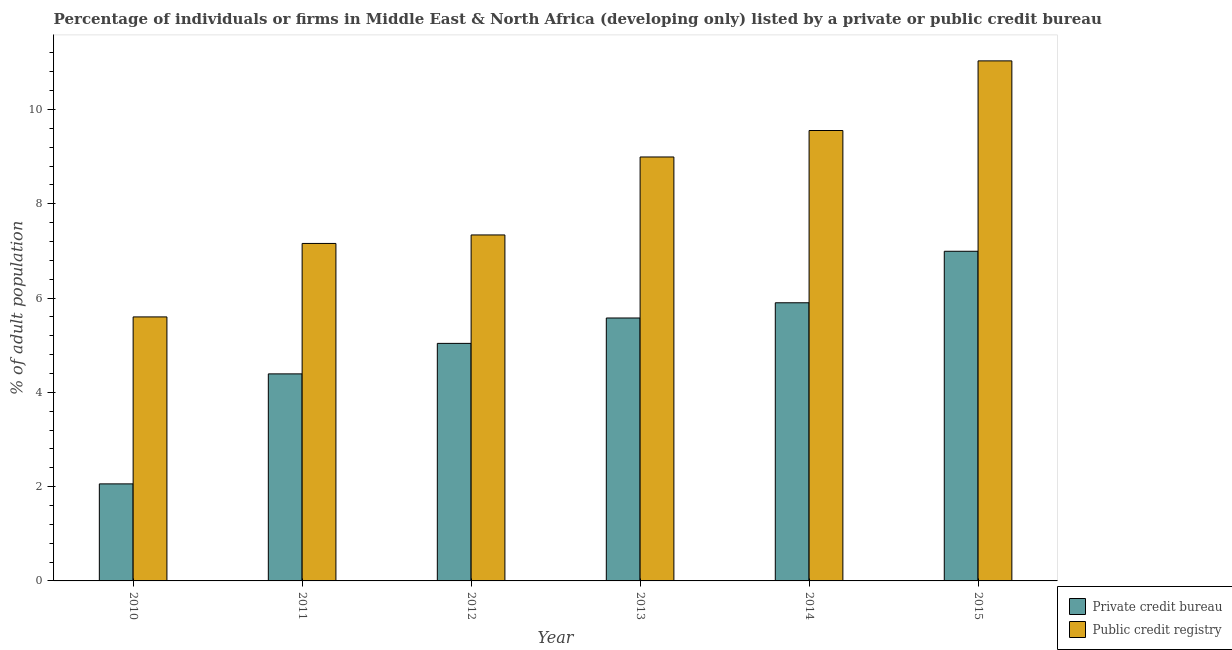How many groups of bars are there?
Ensure brevity in your answer.  6. Are the number of bars on each tick of the X-axis equal?
Your answer should be very brief. Yes. How many bars are there on the 3rd tick from the left?
Keep it short and to the point. 2. What is the label of the 1st group of bars from the left?
Your answer should be very brief. 2010. What is the percentage of firms listed by public credit bureau in 2014?
Provide a short and direct response. 9.55. Across all years, what is the maximum percentage of firms listed by public credit bureau?
Your response must be concise. 11.03. In which year was the percentage of firms listed by public credit bureau maximum?
Your answer should be very brief. 2015. What is the total percentage of firms listed by private credit bureau in the graph?
Offer a very short reply. 29.96. What is the difference between the percentage of firms listed by public credit bureau in 2010 and that in 2015?
Your response must be concise. -5.43. What is the difference between the percentage of firms listed by public credit bureau in 2010 and the percentage of firms listed by private credit bureau in 2014?
Ensure brevity in your answer.  -3.95. What is the average percentage of firms listed by private credit bureau per year?
Your answer should be compact. 4.99. In how many years, is the percentage of firms listed by public credit bureau greater than 2.8 %?
Ensure brevity in your answer.  6. What is the ratio of the percentage of firms listed by private credit bureau in 2011 to that in 2012?
Make the answer very short. 0.87. What is the difference between the highest and the second highest percentage of firms listed by private credit bureau?
Your answer should be compact. 1.09. What is the difference between the highest and the lowest percentage of firms listed by private credit bureau?
Offer a very short reply. 4.93. Is the sum of the percentage of firms listed by private credit bureau in 2011 and 2013 greater than the maximum percentage of firms listed by public credit bureau across all years?
Give a very brief answer. Yes. What does the 1st bar from the left in 2015 represents?
Provide a succinct answer. Private credit bureau. What does the 2nd bar from the right in 2011 represents?
Your answer should be very brief. Private credit bureau. Where does the legend appear in the graph?
Give a very brief answer. Bottom right. How many legend labels are there?
Provide a succinct answer. 2. How are the legend labels stacked?
Offer a terse response. Vertical. What is the title of the graph?
Make the answer very short. Percentage of individuals or firms in Middle East & North Africa (developing only) listed by a private or public credit bureau. Does "Long-term debt" appear as one of the legend labels in the graph?
Provide a short and direct response. No. What is the label or title of the Y-axis?
Make the answer very short. % of adult population. What is the % of adult population of Private credit bureau in 2010?
Ensure brevity in your answer.  2.06. What is the % of adult population in Private credit bureau in 2011?
Your response must be concise. 4.39. What is the % of adult population of Public credit registry in 2011?
Your response must be concise. 7.16. What is the % of adult population in Private credit bureau in 2012?
Provide a short and direct response. 5.04. What is the % of adult population of Public credit registry in 2012?
Offer a terse response. 7.34. What is the % of adult population in Private credit bureau in 2013?
Your response must be concise. 5.58. What is the % of adult population of Public credit registry in 2013?
Ensure brevity in your answer.  8.99. What is the % of adult population in Private credit bureau in 2014?
Keep it short and to the point. 5.9. What is the % of adult population in Public credit registry in 2014?
Offer a terse response. 9.55. What is the % of adult population of Private credit bureau in 2015?
Ensure brevity in your answer.  6.99. What is the % of adult population of Public credit registry in 2015?
Ensure brevity in your answer.  11.03. Across all years, what is the maximum % of adult population of Private credit bureau?
Keep it short and to the point. 6.99. Across all years, what is the maximum % of adult population in Public credit registry?
Offer a terse response. 11.03. Across all years, what is the minimum % of adult population in Private credit bureau?
Provide a succinct answer. 2.06. Across all years, what is the minimum % of adult population of Public credit registry?
Provide a succinct answer. 5.6. What is the total % of adult population of Private credit bureau in the graph?
Offer a terse response. 29.96. What is the total % of adult population of Public credit registry in the graph?
Ensure brevity in your answer.  49.67. What is the difference between the % of adult population of Private credit bureau in 2010 and that in 2011?
Your response must be concise. -2.33. What is the difference between the % of adult population in Public credit registry in 2010 and that in 2011?
Give a very brief answer. -1.56. What is the difference between the % of adult population in Private credit bureau in 2010 and that in 2012?
Your response must be concise. -2.98. What is the difference between the % of adult population in Public credit registry in 2010 and that in 2012?
Offer a very short reply. -1.74. What is the difference between the % of adult population of Private credit bureau in 2010 and that in 2013?
Give a very brief answer. -3.52. What is the difference between the % of adult population of Public credit registry in 2010 and that in 2013?
Your answer should be compact. -3.39. What is the difference between the % of adult population of Private credit bureau in 2010 and that in 2014?
Ensure brevity in your answer.  -3.84. What is the difference between the % of adult population in Public credit registry in 2010 and that in 2014?
Provide a short and direct response. -3.95. What is the difference between the % of adult population in Private credit bureau in 2010 and that in 2015?
Ensure brevity in your answer.  -4.93. What is the difference between the % of adult population in Public credit registry in 2010 and that in 2015?
Ensure brevity in your answer.  -5.43. What is the difference between the % of adult population in Private credit bureau in 2011 and that in 2012?
Your answer should be compact. -0.65. What is the difference between the % of adult population in Public credit registry in 2011 and that in 2012?
Your answer should be very brief. -0.18. What is the difference between the % of adult population in Private credit bureau in 2011 and that in 2013?
Make the answer very short. -1.19. What is the difference between the % of adult population in Public credit registry in 2011 and that in 2013?
Provide a succinct answer. -1.83. What is the difference between the % of adult population of Private credit bureau in 2011 and that in 2014?
Your response must be concise. -1.51. What is the difference between the % of adult population of Public credit registry in 2011 and that in 2014?
Your answer should be compact. -2.4. What is the difference between the % of adult population of Private credit bureau in 2011 and that in 2015?
Offer a very short reply. -2.6. What is the difference between the % of adult population in Public credit registry in 2011 and that in 2015?
Your response must be concise. -3.87. What is the difference between the % of adult population in Private credit bureau in 2012 and that in 2013?
Provide a succinct answer. -0.54. What is the difference between the % of adult population in Public credit registry in 2012 and that in 2013?
Offer a very short reply. -1.65. What is the difference between the % of adult population of Private credit bureau in 2012 and that in 2014?
Keep it short and to the point. -0.86. What is the difference between the % of adult population in Public credit registry in 2012 and that in 2014?
Give a very brief answer. -2.22. What is the difference between the % of adult population in Private credit bureau in 2012 and that in 2015?
Your response must be concise. -1.95. What is the difference between the % of adult population of Public credit registry in 2012 and that in 2015?
Your answer should be very brief. -3.69. What is the difference between the % of adult population of Private credit bureau in 2013 and that in 2014?
Your answer should be compact. -0.32. What is the difference between the % of adult population in Public credit registry in 2013 and that in 2014?
Your answer should be very brief. -0.56. What is the difference between the % of adult population of Private credit bureau in 2013 and that in 2015?
Make the answer very short. -1.42. What is the difference between the % of adult population of Public credit registry in 2013 and that in 2015?
Your answer should be compact. -2.04. What is the difference between the % of adult population in Private credit bureau in 2014 and that in 2015?
Make the answer very short. -1.09. What is the difference between the % of adult population of Public credit registry in 2014 and that in 2015?
Offer a terse response. -1.48. What is the difference between the % of adult population of Private credit bureau in 2010 and the % of adult population of Public credit registry in 2011?
Your answer should be very brief. -5.1. What is the difference between the % of adult population in Private credit bureau in 2010 and the % of adult population in Public credit registry in 2012?
Offer a terse response. -5.28. What is the difference between the % of adult population in Private credit bureau in 2010 and the % of adult population in Public credit registry in 2013?
Offer a terse response. -6.93. What is the difference between the % of adult population of Private credit bureau in 2010 and the % of adult population of Public credit registry in 2014?
Offer a very short reply. -7.5. What is the difference between the % of adult population of Private credit bureau in 2010 and the % of adult population of Public credit registry in 2015?
Offer a very short reply. -8.97. What is the difference between the % of adult population of Private credit bureau in 2011 and the % of adult population of Public credit registry in 2012?
Ensure brevity in your answer.  -2.95. What is the difference between the % of adult population in Private credit bureau in 2011 and the % of adult population in Public credit registry in 2013?
Offer a very short reply. -4.6. What is the difference between the % of adult population in Private credit bureau in 2011 and the % of adult population in Public credit registry in 2014?
Your response must be concise. -5.16. What is the difference between the % of adult population in Private credit bureau in 2011 and the % of adult population in Public credit registry in 2015?
Provide a succinct answer. -6.64. What is the difference between the % of adult population of Private credit bureau in 2012 and the % of adult population of Public credit registry in 2013?
Ensure brevity in your answer.  -3.95. What is the difference between the % of adult population of Private credit bureau in 2012 and the % of adult population of Public credit registry in 2014?
Ensure brevity in your answer.  -4.52. What is the difference between the % of adult population in Private credit bureau in 2012 and the % of adult population in Public credit registry in 2015?
Offer a very short reply. -5.99. What is the difference between the % of adult population in Private credit bureau in 2013 and the % of adult population in Public credit registry in 2014?
Offer a very short reply. -3.98. What is the difference between the % of adult population of Private credit bureau in 2013 and the % of adult population of Public credit registry in 2015?
Offer a terse response. -5.45. What is the difference between the % of adult population of Private credit bureau in 2014 and the % of adult population of Public credit registry in 2015?
Your response must be concise. -5.13. What is the average % of adult population of Private credit bureau per year?
Your response must be concise. 4.99. What is the average % of adult population in Public credit registry per year?
Offer a very short reply. 8.28. In the year 2010, what is the difference between the % of adult population of Private credit bureau and % of adult population of Public credit registry?
Ensure brevity in your answer.  -3.54. In the year 2011, what is the difference between the % of adult population of Private credit bureau and % of adult population of Public credit registry?
Make the answer very short. -2.77. In the year 2012, what is the difference between the % of adult population of Private credit bureau and % of adult population of Public credit registry?
Your answer should be very brief. -2.3. In the year 2013, what is the difference between the % of adult population of Private credit bureau and % of adult population of Public credit registry?
Offer a terse response. -3.42. In the year 2014, what is the difference between the % of adult population of Private credit bureau and % of adult population of Public credit registry?
Your answer should be very brief. -3.65. In the year 2015, what is the difference between the % of adult population of Private credit bureau and % of adult population of Public credit registry?
Offer a very short reply. -4.04. What is the ratio of the % of adult population in Private credit bureau in 2010 to that in 2011?
Your answer should be compact. 0.47. What is the ratio of the % of adult population of Public credit registry in 2010 to that in 2011?
Provide a succinct answer. 0.78. What is the ratio of the % of adult population of Private credit bureau in 2010 to that in 2012?
Provide a short and direct response. 0.41. What is the ratio of the % of adult population in Public credit registry in 2010 to that in 2012?
Your answer should be very brief. 0.76. What is the ratio of the % of adult population of Private credit bureau in 2010 to that in 2013?
Your answer should be compact. 0.37. What is the ratio of the % of adult population in Public credit registry in 2010 to that in 2013?
Your answer should be very brief. 0.62. What is the ratio of the % of adult population in Private credit bureau in 2010 to that in 2014?
Give a very brief answer. 0.35. What is the ratio of the % of adult population in Public credit registry in 2010 to that in 2014?
Provide a succinct answer. 0.59. What is the ratio of the % of adult population in Private credit bureau in 2010 to that in 2015?
Your answer should be compact. 0.29. What is the ratio of the % of adult population of Public credit registry in 2010 to that in 2015?
Ensure brevity in your answer.  0.51. What is the ratio of the % of adult population in Private credit bureau in 2011 to that in 2012?
Your answer should be very brief. 0.87. What is the ratio of the % of adult population of Public credit registry in 2011 to that in 2012?
Ensure brevity in your answer.  0.98. What is the ratio of the % of adult population in Private credit bureau in 2011 to that in 2013?
Provide a short and direct response. 0.79. What is the ratio of the % of adult population in Public credit registry in 2011 to that in 2013?
Your response must be concise. 0.8. What is the ratio of the % of adult population of Private credit bureau in 2011 to that in 2014?
Make the answer very short. 0.74. What is the ratio of the % of adult population in Public credit registry in 2011 to that in 2014?
Keep it short and to the point. 0.75. What is the ratio of the % of adult population of Private credit bureau in 2011 to that in 2015?
Give a very brief answer. 0.63. What is the ratio of the % of adult population in Public credit registry in 2011 to that in 2015?
Provide a short and direct response. 0.65. What is the ratio of the % of adult population in Private credit bureau in 2012 to that in 2013?
Ensure brevity in your answer.  0.9. What is the ratio of the % of adult population in Public credit registry in 2012 to that in 2013?
Offer a terse response. 0.82. What is the ratio of the % of adult population in Private credit bureau in 2012 to that in 2014?
Your answer should be very brief. 0.85. What is the ratio of the % of adult population of Public credit registry in 2012 to that in 2014?
Provide a short and direct response. 0.77. What is the ratio of the % of adult population in Private credit bureau in 2012 to that in 2015?
Give a very brief answer. 0.72. What is the ratio of the % of adult population of Public credit registry in 2012 to that in 2015?
Give a very brief answer. 0.67. What is the ratio of the % of adult population of Private credit bureau in 2013 to that in 2014?
Keep it short and to the point. 0.95. What is the ratio of the % of adult population in Public credit registry in 2013 to that in 2014?
Offer a terse response. 0.94. What is the ratio of the % of adult population in Private credit bureau in 2013 to that in 2015?
Your answer should be very brief. 0.8. What is the ratio of the % of adult population of Public credit registry in 2013 to that in 2015?
Your answer should be compact. 0.82. What is the ratio of the % of adult population in Private credit bureau in 2014 to that in 2015?
Ensure brevity in your answer.  0.84. What is the ratio of the % of adult population in Public credit registry in 2014 to that in 2015?
Ensure brevity in your answer.  0.87. What is the difference between the highest and the second highest % of adult population of Private credit bureau?
Make the answer very short. 1.09. What is the difference between the highest and the second highest % of adult population in Public credit registry?
Your answer should be very brief. 1.48. What is the difference between the highest and the lowest % of adult population in Private credit bureau?
Your response must be concise. 4.93. What is the difference between the highest and the lowest % of adult population of Public credit registry?
Offer a terse response. 5.43. 